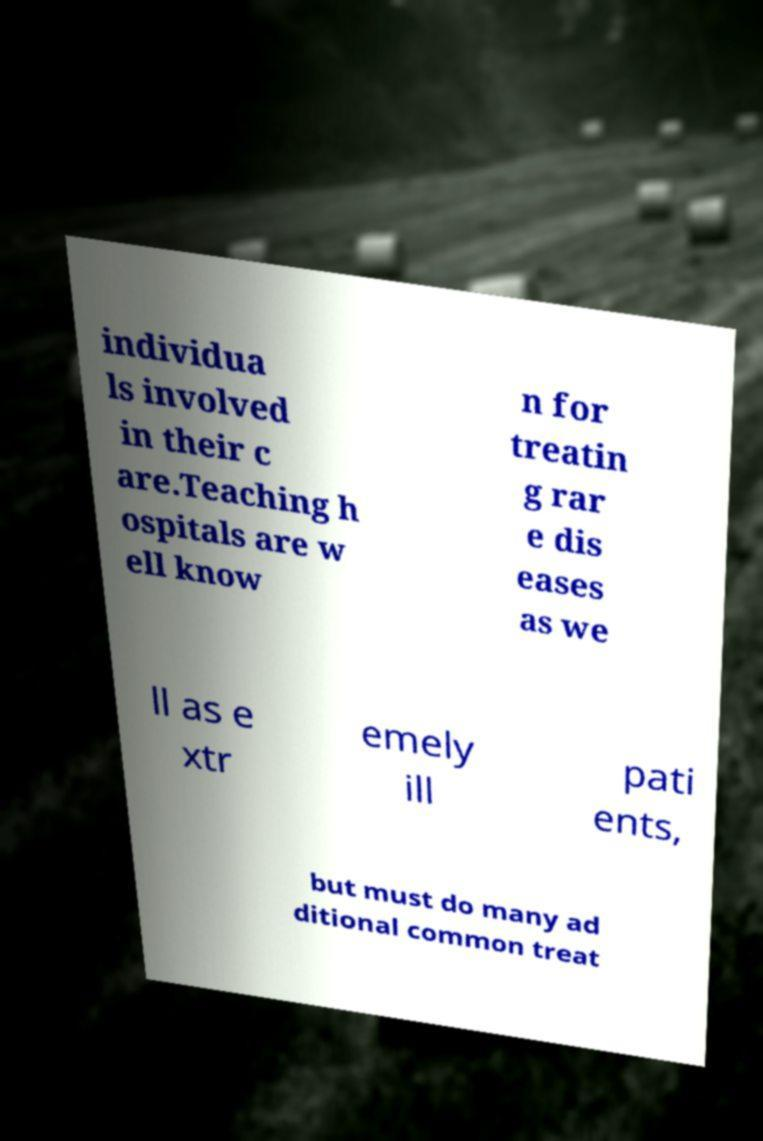Could you extract and type out the text from this image? individua ls involved in their c are.Teaching h ospitals are w ell know n for treatin g rar e dis eases as we ll as e xtr emely ill pati ents, but must do many ad ditional common treat 